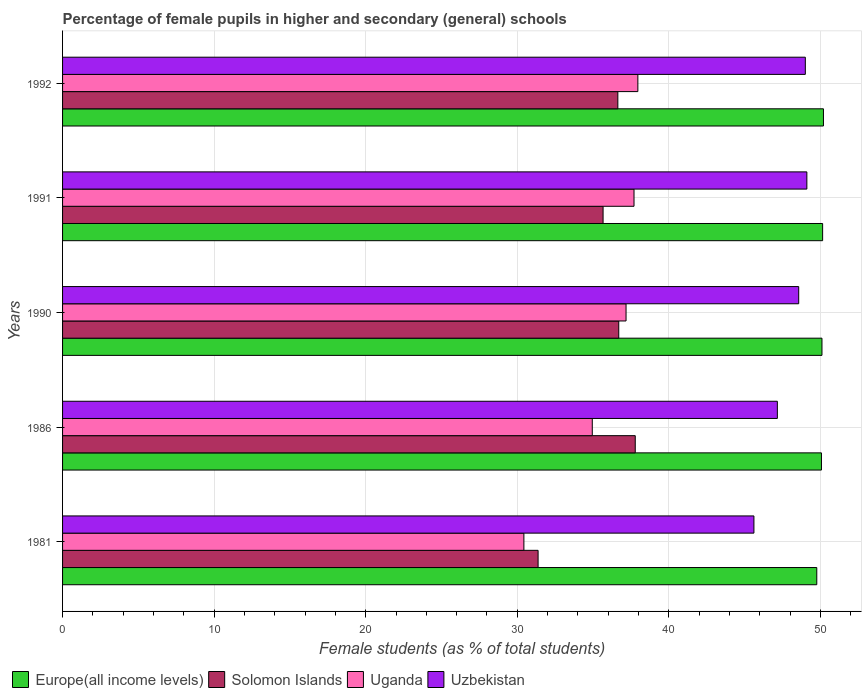How many different coloured bars are there?
Your answer should be compact. 4. How many groups of bars are there?
Provide a short and direct response. 5. Are the number of bars per tick equal to the number of legend labels?
Your answer should be very brief. Yes. Are the number of bars on each tick of the Y-axis equal?
Offer a very short reply. Yes. How many bars are there on the 4th tick from the top?
Your answer should be very brief. 4. How many bars are there on the 4th tick from the bottom?
Your answer should be very brief. 4. What is the label of the 2nd group of bars from the top?
Offer a very short reply. 1991. In how many cases, is the number of bars for a given year not equal to the number of legend labels?
Make the answer very short. 0. What is the percentage of female pupils in higher and secondary schools in Uzbekistan in 1981?
Provide a short and direct response. 45.61. Across all years, what is the maximum percentage of female pupils in higher and secondary schools in Uganda?
Give a very brief answer. 37.95. Across all years, what is the minimum percentage of female pupils in higher and secondary schools in Uganda?
Provide a succinct answer. 30.43. In which year was the percentage of female pupils in higher and secondary schools in Europe(all income levels) maximum?
Your answer should be very brief. 1992. What is the total percentage of female pupils in higher and secondary schools in Uganda in the graph?
Offer a very short reply. 178.21. What is the difference between the percentage of female pupils in higher and secondary schools in Uzbekistan in 1981 and that in 1991?
Keep it short and to the point. -3.49. What is the difference between the percentage of female pupils in higher and secondary schools in Uganda in 1981 and the percentage of female pupils in higher and secondary schools in Europe(all income levels) in 1992?
Ensure brevity in your answer.  -19.76. What is the average percentage of female pupils in higher and secondary schools in Solomon Islands per year?
Your answer should be very brief. 35.63. In the year 1986, what is the difference between the percentage of female pupils in higher and secondary schools in Uzbekistan and percentage of female pupils in higher and secondary schools in Solomon Islands?
Your answer should be compact. 9.38. In how many years, is the percentage of female pupils in higher and secondary schools in Solomon Islands greater than 46 %?
Offer a very short reply. 0. What is the ratio of the percentage of female pupils in higher and secondary schools in Solomon Islands in 1986 to that in 1991?
Your response must be concise. 1.06. Is the percentage of female pupils in higher and secondary schools in Uzbekistan in 1981 less than that in 1992?
Your answer should be compact. Yes. What is the difference between the highest and the second highest percentage of female pupils in higher and secondary schools in Solomon Islands?
Ensure brevity in your answer.  1.09. What is the difference between the highest and the lowest percentage of female pupils in higher and secondary schools in Uzbekistan?
Your answer should be compact. 3.49. What does the 3rd bar from the top in 1990 represents?
Provide a succinct answer. Solomon Islands. What does the 3rd bar from the bottom in 1981 represents?
Your answer should be very brief. Uganda. Is it the case that in every year, the sum of the percentage of female pupils in higher and secondary schools in Uganda and percentage of female pupils in higher and secondary schools in Solomon Islands is greater than the percentage of female pupils in higher and secondary schools in Uzbekistan?
Give a very brief answer. Yes. Are all the bars in the graph horizontal?
Ensure brevity in your answer.  Yes. How many years are there in the graph?
Your response must be concise. 5. What is the difference between two consecutive major ticks on the X-axis?
Your answer should be very brief. 10. Are the values on the major ticks of X-axis written in scientific E-notation?
Your answer should be compact. No. Does the graph contain any zero values?
Provide a short and direct response. No. Does the graph contain grids?
Your response must be concise. Yes. How many legend labels are there?
Give a very brief answer. 4. How are the legend labels stacked?
Your response must be concise. Horizontal. What is the title of the graph?
Give a very brief answer. Percentage of female pupils in higher and secondary (general) schools. What is the label or title of the X-axis?
Make the answer very short. Female students (as % of total students). What is the Female students (as % of total students) in Europe(all income levels) in 1981?
Make the answer very short. 49.76. What is the Female students (as % of total students) of Solomon Islands in 1981?
Ensure brevity in your answer.  31.37. What is the Female students (as % of total students) of Uganda in 1981?
Make the answer very short. 30.43. What is the Female students (as % of total students) in Uzbekistan in 1981?
Your answer should be compact. 45.61. What is the Female students (as % of total students) in Europe(all income levels) in 1986?
Your answer should be very brief. 50.07. What is the Female students (as % of total students) of Solomon Islands in 1986?
Provide a succinct answer. 37.78. What is the Female students (as % of total students) of Uganda in 1986?
Ensure brevity in your answer.  34.95. What is the Female students (as % of total students) in Uzbekistan in 1986?
Your answer should be very brief. 47.16. What is the Female students (as % of total students) in Europe(all income levels) in 1990?
Offer a terse response. 50.1. What is the Female students (as % of total students) of Solomon Islands in 1990?
Your response must be concise. 36.69. What is the Female students (as % of total students) of Uganda in 1990?
Your response must be concise. 37.17. What is the Female students (as % of total students) in Uzbekistan in 1990?
Provide a short and direct response. 48.57. What is the Female students (as % of total students) of Europe(all income levels) in 1991?
Give a very brief answer. 50.14. What is the Female students (as % of total students) in Solomon Islands in 1991?
Provide a short and direct response. 35.66. What is the Female students (as % of total students) in Uganda in 1991?
Keep it short and to the point. 37.7. What is the Female students (as % of total students) in Uzbekistan in 1991?
Keep it short and to the point. 49.1. What is the Female students (as % of total students) in Europe(all income levels) in 1992?
Give a very brief answer. 50.2. What is the Female students (as % of total students) in Solomon Islands in 1992?
Give a very brief answer. 36.63. What is the Female students (as % of total students) in Uganda in 1992?
Ensure brevity in your answer.  37.95. What is the Female students (as % of total students) in Uzbekistan in 1992?
Provide a succinct answer. 49. Across all years, what is the maximum Female students (as % of total students) of Europe(all income levels)?
Your answer should be compact. 50.2. Across all years, what is the maximum Female students (as % of total students) of Solomon Islands?
Your response must be concise. 37.78. Across all years, what is the maximum Female students (as % of total students) in Uganda?
Keep it short and to the point. 37.95. Across all years, what is the maximum Female students (as % of total students) of Uzbekistan?
Your answer should be compact. 49.1. Across all years, what is the minimum Female students (as % of total students) in Europe(all income levels)?
Offer a terse response. 49.76. Across all years, what is the minimum Female students (as % of total students) of Solomon Islands?
Provide a succinct answer. 31.37. Across all years, what is the minimum Female students (as % of total students) of Uganda?
Give a very brief answer. 30.43. Across all years, what is the minimum Female students (as % of total students) of Uzbekistan?
Offer a very short reply. 45.61. What is the total Female students (as % of total students) of Europe(all income levels) in the graph?
Your response must be concise. 250.26. What is the total Female students (as % of total students) of Solomon Islands in the graph?
Your answer should be very brief. 178.14. What is the total Female students (as % of total students) in Uganda in the graph?
Provide a short and direct response. 178.21. What is the total Female students (as % of total students) of Uzbekistan in the graph?
Make the answer very short. 239.44. What is the difference between the Female students (as % of total students) of Europe(all income levels) in 1981 and that in 1986?
Give a very brief answer. -0.31. What is the difference between the Female students (as % of total students) in Solomon Islands in 1981 and that in 1986?
Offer a terse response. -6.41. What is the difference between the Female students (as % of total students) in Uganda in 1981 and that in 1986?
Offer a very short reply. -4.51. What is the difference between the Female students (as % of total students) of Uzbekistan in 1981 and that in 1986?
Offer a terse response. -1.55. What is the difference between the Female students (as % of total students) in Europe(all income levels) in 1981 and that in 1990?
Your response must be concise. -0.34. What is the difference between the Female students (as % of total students) in Solomon Islands in 1981 and that in 1990?
Your answer should be very brief. -5.32. What is the difference between the Female students (as % of total students) in Uganda in 1981 and that in 1990?
Offer a very short reply. -6.74. What is the difference between the Female students (as % of total students) in Uzbekistan in 1981 and that in 1990?
Your answer should be very brief. -2.95. What is the difference between the Female students (as % of total students) of Europe(all income levels) in 1981 and that in 1991?
Give a very brief answer. -0.39. What is the difference between the Female students (as % of total students) in Solomon Islands in 1981 and that in 1991?
Your response must be concise. -4.29. What is the difference between the Female students (as % of total students) in Uganda in 1981 and that in 1991?
Provide a short and direct response. -7.27. What is the difference between the Female students (as % of total students) in Uzbekistan in 1981 and that in 1991?
Offer a terse response. -3.49. What is the difference between the Female students (as % of total students) of Europe(all income levels) in 1981 and that in 1992?
Your response must be concise. -0.44. What is the difference between the Female students (as % of total students) of Solomon Islands in 1981 and that in 1992?
Give a very brief answer. -5.26. What is the difference between the Female students (as % of total students) in Uganda in 1981 and that in 1992?
Your answer should be very brief. -7.52. What is the difference between the Female students (as % of total students) of Uzbekistan in 1981 and that in 1992?
Keep it short and to the point. -3.39. What is the difference between the Female students (as % of total students) of Europe(all income levels) in 1986 and that in 1990?
Give a very brief answer. -0.03. What is the difference between the Female students (as % of total students) in Solomon Islands in 1986 and that in 1990?
Offer a terse response. 1.09. What is the difference between the Female students (as % of total students) in Uganda in 1986 and that in 1990?
Your response must be concise. -2.23. What is the difference between the Female students (as % of total students) in Uzbekistan in 1986 and that in 1990?
Your response must be concise. -1.41. What is the difference between the Female students (as % of total students) in Europe(all income levels) in 1986 and that in 1991?
Give a very brief answer. -0.08. What is the difference between the Female students (as % of total students) in Solomon Islands in 1986 and that in 1991?
Offer a terse response. 2.12. What is the difference between the Female students (as % of total students) in Uganda in 1986 and that in 1991?
Provide a short and direct response. -2.75. What is the difference between the Female students (as % of total students) of Uzbekistan in 1986 and that in 1991?
Your response must be concise. -1.95. What is the difference between the Female students (as % of total students) in Europe(all income levels) in 1986 and that in 1992?
Your answer should be compact. -0.13. What is the difference between the Female students (as % of total students) of Solomon Islands in 1986 and that in 1992?
Your answer should be compact. 1.15. What is the difference between the Female students (as % of total students) in Uganda in 1986 and that in 1992?
Provide a succinct answer. -3.01. What is the difference between the Female students (as % of total students) of Uzbekistan in 1986 and that in 1992?
Provide a succinct answer. -1.85. What is the difference between the Female students (as % of total students) of Europe(all income levels) in 1990 and that in 1991?
Make the answer very short. -0.04. What is the difference between the Female students (as % of total students) in Solomon Islands in 1990 and that in 1991?
Offer a terse response. 1.03. What is the difference between the Female students (as % of total students) of Uganda in 1990 and that in 1991?
Your answer should be very brief. -0.53. What is the difference between the Female students (as % of total students) of Uzbekistan in 1990 and that in 1991?
Keep it short and to the point. -0.54. What is the difference between the Female students (as % of total students) in Europe(all income levels) in 1990 and that in 1992?
Make the answer very short. -0.1. What is the difference between the Female students (as % of total students) in Solomon Islands in 1990 and that in 1992?
Your answer should be very brief. 0.06. What is the difference between the Female students (as % of total students) in Uganda in 1990 and that in 1992?
Your response must be concise. -0.78. What is the difference between the Female students (as % of total students) in Uzbekistan in 1990 and that in 1992?
Offer a terse response. -0.44. What is the difference between the Female students (as % of total students) of Europe(all income levels) in 1991 and that in 1992?
Your answer should be compact. -0.05. What is the difference between the Female students (as % of total students) of Solomon Islands in 1991 and that in 1992?
Ensure brevity in your answer.  -0.97. What is the difference between the Female students (as % of total students) in Uganda in 1991 and that in 1992?
Your response must be concise. -0.25. What is the difference between the Female students (as % of total students) of Uzbekistan in 1991 and that in 1992?
Offer a very short reply. 0.1. What is the difference between the Female students (as % of total students) in Europe(all income levels) in 1981 and the Female students (as % of total students) in Solomon Islands in 1986?
Provide a short and direct response. 11.98. What is the difference between the Female students (as % of total students) in Europe(all income levels) in 1981 and the Female students (as % of total students) in Uganda in 1986?
Make the answer very short. 14.81. What is the difference between the Female students (as % of total students) of Europe(all income levels) in 1981 and the Female students (as % of total students) of Uzbekistan in 1986?
Ensure brevity in your answer.  2.6. What is the difference between the Female students (as % of total students) in Solomon Islands in 1981 and the Female students (as % of total students) in Uganda in 1986?
Provide a succinct answer. -3.58. What is the difference between the Female students (as % of total students) of Solomon Islands in 1981 and the Female students (as % of total students) of Uzbekistan in 1986?
Your response must be concise. -15.79. What is the difference between the Female students (as % of total students) in Uganda in 1981 and the Female students (as % of total students) in Uzbekistan in 1986?
Offer a terse response. -16.72. What is the difference between the Female students (as % of total students) of Europe(all income levels) in 1981 and the Female students (as % of total students) of Solomon Islands in 1990?
Your answer should be very brief. 13.06. What is the difference between the Female students (as % of total students) in Europe(all income levels) in 1981 and the Female students (as % of total students) in Uganda in 1990?
Provide a succinct answer. 12.58. What is the difference between the Female students (as % of total students) of Europe(all income levels) in 1981 and the Female students (as % of total students) of Uzbekistan in 1990?
Your response must be concise. 1.19. What is the difference between the Female students (as % of total students) of Solomon Islands in 1981 and the Female students (as % of total students) of Uganda in 1990?
Offer a terse response. -5.8. What is the difference between the Female students (as % of total students) in Solomon Islands in 1981 and the Female students (as % of total students) in Uzbekistan in 1990?
Your answer should be compact. -17.19. What is the difference between the Female students (as % of total students) in Uganda in 1981 and the Female students (as % of total students) in Uzbekistan in 1990?
Provide a succinct answer. -18.13. What is the difference between the Female students (as % of total students) in Europe(all income levels) in 1981 and the Female students (as % of total students) in Solomon Islands in 1991?
Provide a succinct answer. 14.1. What is the difference between the Female students (as % of total students) of Europe(all income levels) in 1981 and the Female students (as % of total students) of Uganda in 1991?
Give a very brief answer. 12.06. What is the difference between the Female students (as % of total students) of Europe(all income levels) in 1981 and the Female students (as % of total students) of Uzbekistan in 1991?
Your response must be concise. 0.65. What is the difference between the Female students (as % of total students) of Solomon Islands in 1981 and the Female students (as % of total students) of Uganda in 1991?
Provide a short and direct response. -6.33. What is the difference between the Female students (as % of total students) in Solomon Islands in 1981 and the Female students (as % of total students) in Uzbekistan in 1991?
Your response must be concise. -17.73. What is the difference between the Female students (as % of total students) in Uganda in 1981 and the Female students (as % of total students) in Uzbekistan in 1991?
Your answer should be compact. -18.67. What is the difference between the Female students (as % of total students) of Europe(all income levels) in 1981 and the Female students (as % of total students) of Solomon Islands in 1992?
Keep it short and to the point. 13.12. What is the difference between the Female students (as % of total students) of Europe(all income levels) in 1981 and the Female students (as % of total students) of Uganda in 1992?
Provide a short and direct response. 11.8. What is the difference between the Female students (as % of total students) in Europe(all income levels) in 1981 and the Female students (as % of total students) in Uzbekistan in 1992?
Keep it short and to the point. 0.76. What is the difference between the Female students (as % of total students) of Solomon Islands in 1981 and the Female students (as % of total students) of Uganda in 1992?
Give a very brief answer. -6.58. What is the difference between the Female students (as % of total students) in Solomon Islands in 1981 and the Female students (as % of total students) in Uzbekistan in 1992?
Ensure brevity in your answer.  -17.63. What is the difference between the Female students (as % of total students) of Uganda in 1981 and the Female students (as % of total students) of Uzbekistan in 1992?
Your answer should be very brief. -18.57. What is the difference between the Female students (as % of total students) in Europe(all income levels) in 1986 and the Female students (as % of total students) in Solomon Islands in 1990?
Ensure brevity in your answer.  13.37. What is the difference between the Female students (as % of total students) in Europe(all income levels) in 1986 and the Female students (as % of total students) in Uganda in 1990?
Make the answer very short. 12.89. What is the difference between the Female students (as % of total students) in Europe(all income levels) in 1986 and the Female students (as % of total students) in Uzbekistan in 1990?
Give a very brief answer. 1.5. What is the difference between the Female students (as % of total students) of Solomon Islands in 1986 and the Female students (as % of total students) of Uganda in 1990?
Offer a very short reply. 0.61. What is the difference between the Female students (as % of total students) of Solomon Islands in 1986 and the Female students (as % of total students) of Uzbekistan in 1990?
Your answer should be very brief. -10.78. What is the difference between the Female students (as % of total students) of Uganda in 1986 and the Female students (as % of total students) of Uzbekistan in 1990?
Your answer should be very brief. -13.62. What is the difference between the Female students (as % of total students) in Europe(all income levels) in 1986 and the Female students (as % of total students) in Solomon Islands in 1991?
Your answer should be very brief. 14.41. What is the difference between the Female students (as % of total students) in Europe(all income levels) in 1986 and the Female students (as % of total students) in Uganda in 1991?
Provide a succinct answer. 12.37. What is the difference between the Female students (as % of total students) of Europe(all income levels) in 1986 and the Female students (as % of total students) of Uzbekistan in 1991?
Your answer should be compact. 0.96. What is the difference between the Female students (as % of total students) of Solomon Islands in 1986 and the Female students (as % of total students) of Uganda in 1991?
Ensure brevity in your answer.  0.08. What is the difference between the Female students (as % of total students) of Solomon Islands in 1986 and the Female students (as % of total students) of Uzbekistan in 1991?
Provide a succinct answer. -11.32. What is the difference between the Female students (as % of total students) of Uganda in 1986 and the Female students (as % of total students) of Uzbekistan in 1991?
Keep it short and to the point. -14.16. What is the difference between the Female students (as % of total students) in Europe(all income levels) in 1986 and the Female students (as % of total students) in Solomon Islands in 1992?
Offer a very short reply. 13.43. What is the difference between the Female students (as % of total students) of Europe(all income levels) in 1986 and the Female students (as % of total students) of Uganda in 1992?
Ensure brevity in your answer.  12.11. What is the difference between the Female students (as % of total students) in Europe(all income levels) in 1986 and the Female students (as % of total students) in Uzbekistan in 1992?
Offer a very short reply. 1.06. What is the difference between the Female students (as % of total students) of Solomon Islands in 1986 and the Female students (as % of total students) of Uganda in 1992?
Provide a succinct answer. -0.17. What is the difference between the Female students (as % of total students) in Solomon Islands in 1986 and the Female students (as % of total students) in Uzbekistan in 1992?
Provide a short and direct response. -11.22. What is the difference between the Female students (as % of total students) in Uganda in 1986 and the Female students (as % of total students) in Uzbekistan in 1992?
Offer a very short reply. -14.06. What is the difference between the Female students (as % of total students) of Europe(all income levels) in 1990 and the Female students (as % of total students) of Solomon Islands in 1991?
Ensure brevity in your answer.  14.44. What is the difference between the Female students (as % of total students) in Europe(all income levels) in 1990 and the Female students (as % of total students) in Uganda in 1991?
Provide a short and direct response. 12.4. What is the difference between the Female students (as % of total students) of Europe(all income levels) in 1990 and the Female students (as % of total students) of Uzbekistan in 1991?
Give a very brief answer. 1. What is the difference between the Female students (as % of total students) in Solomon Islands in 1990 and the Female students (as % of total students) in Uganda in 1991?
Your response must be concise. -1.01. What is the difference between the Female students (as % of total students) in Solomon Islands in 1990 and the Female students (as % of total students) in Uzbekistan in 1991?
Keep it short and to the point. -12.41. What is the difference between the Female students (as % of total students) of Uganda in 1990 and the Female students (as % of total students) of Uzbekistan in 1991?
Make the answer very short. -11.93. What is the difference between the Female students (as % of total students) of Europe(all income levels) in 1990 and the Female students (as % of total students) of Solomon Islands in 1992?
Make the answer very short. 13.47. What is the difference between the Female students (as % of total students) in Europe(all income levels) in 1990 and the Female students (as % of total students) in Uganda in 1992?
Your answer should be very brief. 12.15. What is the difference between the Female students (as % of total students) in Europe(all income levels) in 1990 and the Female students (as % of total students) in Uzbekistan in 1992?
Keep it short and to the point. 1.1. What is the difference between the Female students (as % of total students) in Solomon Islands in 1990 and the Female students (as % of total students) in Uganda in 1992?
Offer a terse response. -1.26. What is the difference between the Female students (as % of total students) in Solomon Islands in 1990 and the Female students (as % of total students) in Uzbekistan in 1992?
Give a very brief answer. -12.31. What is the difference between the Female students (as % of total students) of Uganda in 1990 and the Female students (as % of total students) of Uzbekistan in 1992?
Your answer should be very brief. -11.83. What is the difference between the Female students (as % of total students) in Europe(all income levels) in 1991 and the Female students (as % of total students) in Solomon Islands in 1992?
Make the answer very short. 13.51. What is the difference between the Female students (as % of total students) in Europe(all income levels) in 1991 and the Female students (as % of total students) in Uganda in 1992?
Provide a succinct answer. 12.19. What is the difference between the Female students (as % of total students) in Europe(all income levels) in 1991 and the Female students (as % of total students) in Uzbekistan in 1992?
Provide a short and direct response. 1.14. What is the difference between the Female students (as % of total students) in Solomon Islands in 1991 and the Female students (as % of total students) in Uganda in 1992?
Your answer should be compact. -2.29. What is the difference between the Female students (as % of total students) of Solomon Islands in 1991 and the Female students (as % of total students) of Uzbekistan in 1992?
Offer a terse response. -13.34. What is the difference between the Female students (as % of total students) in Uganda in 1991 and the Female students (as % of total students) in Uzbekistan in 1992?
Provide a short and direct response. -11.3. What is the average Female students (as % of total students) of Europe(all income levels) per year?
Offer a terse response. 50.05. What is the average Female students (as % of total students) of Solomon Islands per year?
Your answer should be compact. 35.63. What is the average Female students (as % of total students) in Uganda per year?
Make the answer very short. 35.64. What is the average Female students (as % of total students) of Uzbekistan per year?
Your response must be concise. 47.89. In the year 1981, what is the difference between the Female students (as % of total students) in Europe(all income levels) and Female students (as % of total students) in Solomon Islands?
Keep it short and to the point. 18.39. In the year 1981, what is the difference between the Female students (as % of total students) in Europe(all income levels) and Female students (as % of total students) in Uganda?
Offer a very short reply. 19.32. In the year 1981, what is the difference between the Female students (as % of total students) of Europe(all income levels) and Female students (as % of total students) of Uzbekistan?
Provide a succinct answer. 4.15. In the year 1981, what is the difference between the Female students (as % of total students) in Solomon Islands and Female students (as % of total students) in Uganda?
Your response must be concise. 0.94. In the year 1981, what is the difference between the Female students (as % of total students) in Solomon Islands and Female students (as % of total students) in Uzbekistan?
Your response must be concise. -14.24. In the year 1981, what is the difference between the Female students (as % of total students) in Uganda and Female students (as % of total students) in Uzbekistan?
Provide a short and direct response. -15.18. In the year 1986, what is the difference between the Female students (as % of total students) in Europe(all income levels) and Female students (as % of total students) in Solomon Islands?
Your response must be concise. 12.28. In the year 1986, what is the difference between the Female students (as % of total students) of Europe(all income levels) and Female students (as % of total students) of Uganda?
Provide a succinct answer. 15.12. In the year 1986, what is the difference between the Female students (as % of total students) in Europe(all income levels) and Female students (as % of total students) in Uzbekistan?
Keep it short and to the point. 2.91. In the year 1986, what is the difference between the Female students (as % of total students) of Solomon Islands and Female students (as % of total students) of Uganda?
Your answer should be very brief. 2.83. In the year 1986, what is the difference between the Female students (as % of total students) in Solomon Islands and Female students (as % of total students) in Uzbekistan?
Your response must be concise. -9.38. In the year 1986, what is the difference between the Female students (as % of total students) of Uganda and Female students (as % of total students) of Uzbekistan?
Your answer should be compact. -12.21. In the year 1990, what is the difference between the Female students (as % of total students) in Europe(all income levels) and Female students (as % of total students) in Solomon Islands?
Offer a very short reply. 13.41. In the year 1990, what is the difference between the Female students (as % of total students) in Europe(all income levels) and Female students (as % of total students) in Uganda?
Provide a succinct answer. 12.93. In the year 1990, what is the difference between the Female students (as % of total students) in Europe(all income levels) and Female students (as % of total students) in Uzbekistan?
Provide a short and direct response. 1.53. In the year 1990, what is the difference between the Female students (as % of total students) in Solomon Islands and Female students (as % of total students) in Uganda?
Offer a very short reply. -0.48. In the year 1990, what is the difference between the Female students (as % of total students) of Solomon Islands and Female students (as % of total students) of Uzbekistan?
Your answer should be compact. -11.87. In the year 1990, what is the difference between the Female students (as % of total students) in Uganda and Female students (as % of total students) in Uzbekistan?
Your response must be concise. -11.39. In the year 1991, what is the difference between the Female students (as % of total students) in Europe(all income levels) and Female students (as % of total students) in Solomon Islands?
Offer a terse response. 14.48. In the year 1991, what is the difference between the Female students (as % of total students) of Europe(all income levels) and Female students (as % of total students) of Uganda?
Make the answer very short. 12.44. In the year 1991, what is the difference between the Female students (as % of total students) in Europe(all income levels) and Female students (as % of total students) in Uzbekistan?
Your answer should be very brief. 1.04. In the year 1991, what is the difference between the Female students (as % of total students) in Solomon Islands and Female students (as % of total students) in Uganda?
Ensure brevity in your answer.  -2.04. In the year 1991, what is the difference between the Female students (as % of total students) in Solomon Islands and Female students (as % of total students) in Uzbekistan?
Offer a very short reply. -13.44. In the year 1991, what is the difference between the Female students (as % of total students) in Uganda and Female students (as % of total students) in Uzbekistan?
Provide a succinct answer. -11.4. In the year 1992, what is the difference between the Female students (as % of total students) of Europe(all income levels) and Female students (as % of total students) of Solomon Islands?
Offer a terse response. 13.56. In the year 1992, what is the difference between the Female students (as % of total students) of Europe(all income levels) and Female students (as % of total students) of Uganda?
Provide a succinct answer. 12.24. In the year 1992, what is the difference between the Female students (as % of total students) in Europe(all income levels) and Female students (as % of total students) in Uzbekistan?
Make the answer very short. 1.2. In the year 1992, what is the difference between the Female students (as % of total students) of Solomon Islands and Female students (as % of total students) of Uganda?
Your answer should be very brief. -1.32. In the year 1992, what is the difference between the Female students (as % of total students) in Solomon Islands and Female students (as % of total students) in Uzbekistan?
Your answer should be very brief. -12.37. In the year 1992, what is the difference between the Female students (as % of total students) in Uganda and Female students (as % of total students) in Uzbekistan?
Your answer should be very brief. -11.05. What is the ratio of the Female students (as % of total students) in Europe(all income levels) in 1981 to that in 1986?
Provide a succinct answer. 0.99. What is the ratio of the Female students (as % of total students) in Solomon Islands in 1981 to that in 1986?
Make the answer very short. 0.83. What is the ratio of the Female students (as % of total students) in Uganda in 1981 to that in 1986?
Provide a short and direct response. 0.87. What is the ratio of the Female students (as % of total students) of Uzbekistan in 1981 to that in 1986?
Your answer should be very brief. 0.97. What is the ratio of the Female students (as % of total students) of Europe(all income levels) in 1981 to that in 1990?
Your answer should be very brief. 0.99. What is the ratio of the Female students (as % of total students) of Solomon Islands in 1981 to that in 1990?
Keep it short and to the point. 0.85. What is the ratio of the Female students (as % of total students) of Uganda in 1981 to that in 1990?
Your answer should be very brief. 0.82. What is the ratio of the Female students (as % of total students) in Uzbekistan in 1981 to that in 1990?
Keep it short and to the point. 0.94. What is the ratio of the Female students (as % of total students) of Solomon Islands in 1981 to that in 1991?
Keep it short and to the point. 0.88. What is the ratio of the Female students (as % of total students) in Uganda in 1981 to that in 1991?
Your answer should be very brief. 0.81. What is the ratio of the Female students (as % of total students) in Uzbekistan in 1981 to that in 1991?
Your answer should be very brief. 0.93. What is the ratio of the Female students (as % of total students) of Europe(all income levels) in 1981 to that in 1992?
Your response must be concise. 0.99. What is the ratio of the Female students (as % of total students) of Solomon Islands in 1981 to that in 1992?
Your answer should be compact. 0.86. What is the ratio of the Female students (as % of total students) in Uganda in 1981 to that in 1992?
Keep it short and to the point. 0.8. What is the ratio of the Female students (as % of total students) in Uzbekistan in 1981 to that in 1992?
Your answer should be very brief. 0.93. What is the ratio of the Female students (as % of total students) of Europe(all income levels) in 1986 to that in 1990?
Offer a terse response. 1. What is the ratio of the Female students (as % of total students) in Solomon Islands in 1986 to that in 1990?
Your answer should be very brief. 1.03. What is the ratio of the Female students (as % of total students) in Uganda in 1986 to that in 1990?
Keep it short and to the point. 0.94. What is the ratio of the Female students (as % of total students) of Europe(all income levels) in 1986 to that in 1991?
Offer a terse response. 1. What is the ratio of the Female students (as % of total students) in Solomon Islands in 1986 to that in 1991?
Offer a terse response. 1.06. What is the ratio of the Female students (as % of total students) of Uganda in 1986 to that in 1991?
Your response must be concise. 0.93. What is the ratio of the Female students (as % of total students) of Uzbekistan in 1986 to that in 1991?
Keep it short and to the point. 0.96. What is the ratio of the Female students (as % of total students) of Europe(all income levels) in 1986 to that in 1992?
Give a very brief answer. 1. What is the ratio of the Female students (as % of total students) in Solomon Islands in 1986 to that in 1992?
Your answer should be very brief. 1.03. What is the ratio of the Female students (as % of total students) of Uganda in 1986 to that in 1992?
Ensure brevity in your answer.  0.92. What is the ratio of the Female students (as % of total students) in Uzbekistan in 1986 to that in 1992?
Provide a succinct answer. 0.96. What is the ratio of the Female students (as % of total students) in Uganda in 1990 to that in 1991?
Your answer should be compact. 0.99. What is the ratio of the Female students (as % of total students) in Europe(all income levels) in 1990 to that in 1992?
Your answer should be very brief. 1. What is the ratio of the Female students (as % of total students) of Solomon Islands in 1990 to that in 1992?
Your response must be concise. 1. What is the ratio of the Female students (as % of total students) in Uganda in 1990 to that in 1992?
Offer a terse response. 0.98. What is the ratio of the Female students (as % of total students) of Europe(all income levels) in 1991 to that in 1992?
Keep it short and to the point. 1. What is the ratio of the Female students (as % of total students) of Solomon Islands in 1991 to that in 1992?
Your answer should be very brief. 0.97. What is the difference between the highest and the second highest Female students (as % of total students) of Europe(all income levels)?
Provide a short and direct response. 0.05. What is the difference between the highest and the second highest Female students (as % of total students) in Solomon Islands?
Keep it short and to the point. 1.09. What is the difference between the highest and the second highest Female students (as % of total students) in Uganda?
Ensure brevity in your answer.  0.25. What is the difference between the highest and the second highest Female students (as % of total students) of Uzbekistan?
Provide a succinct answer. 0.1. What is the difference between the highest and the lowest Female students (as % of total students) of Europe(all income levels)?
Offer a very short reply. 0.44. What is the difference between the highest and the lowest Female students (as % of total students) in Solomon Islands?
Make the answer very short. 6.41. What is the difference between the highest and the lowest Female students (as % of total students) in Uganda?
Offer a very short reply. 7.52. What is the difference between the highest and the lowest Female students (as % of total students) of Uzbekistan?
Your answer should be very brief. 3.49. 